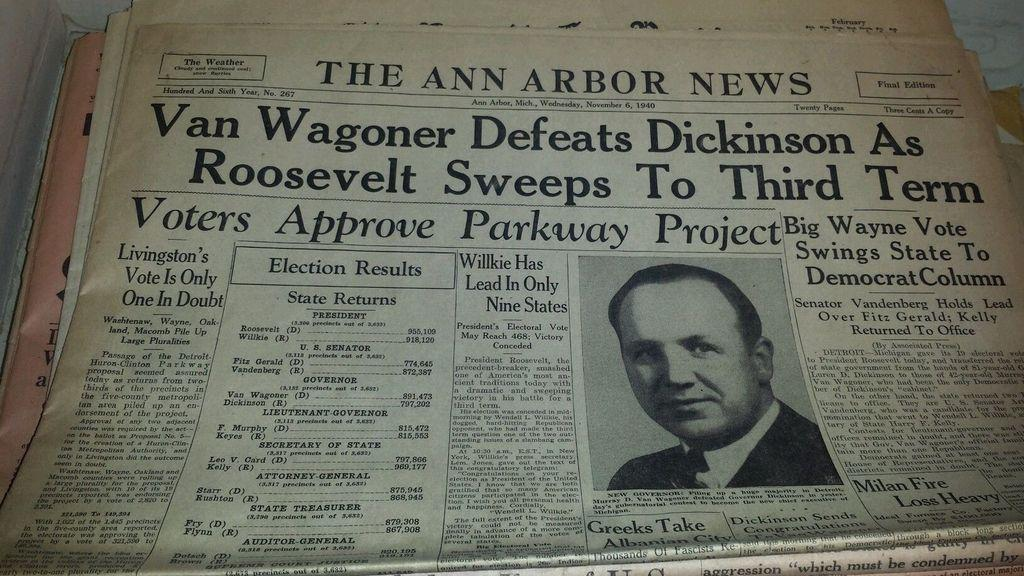What type of printed material is present in the image? There are newspapers in the image. What can be seen on one of the newspapers? A person's photo is visible on one of the newspapers. What is written on the newspaper with the person's photo? There is printed text on the newspaper with the person's photo. How does the person's friend react to the photo in the morning? There is no information about the person's friend or their reaction in the morning in the image. 